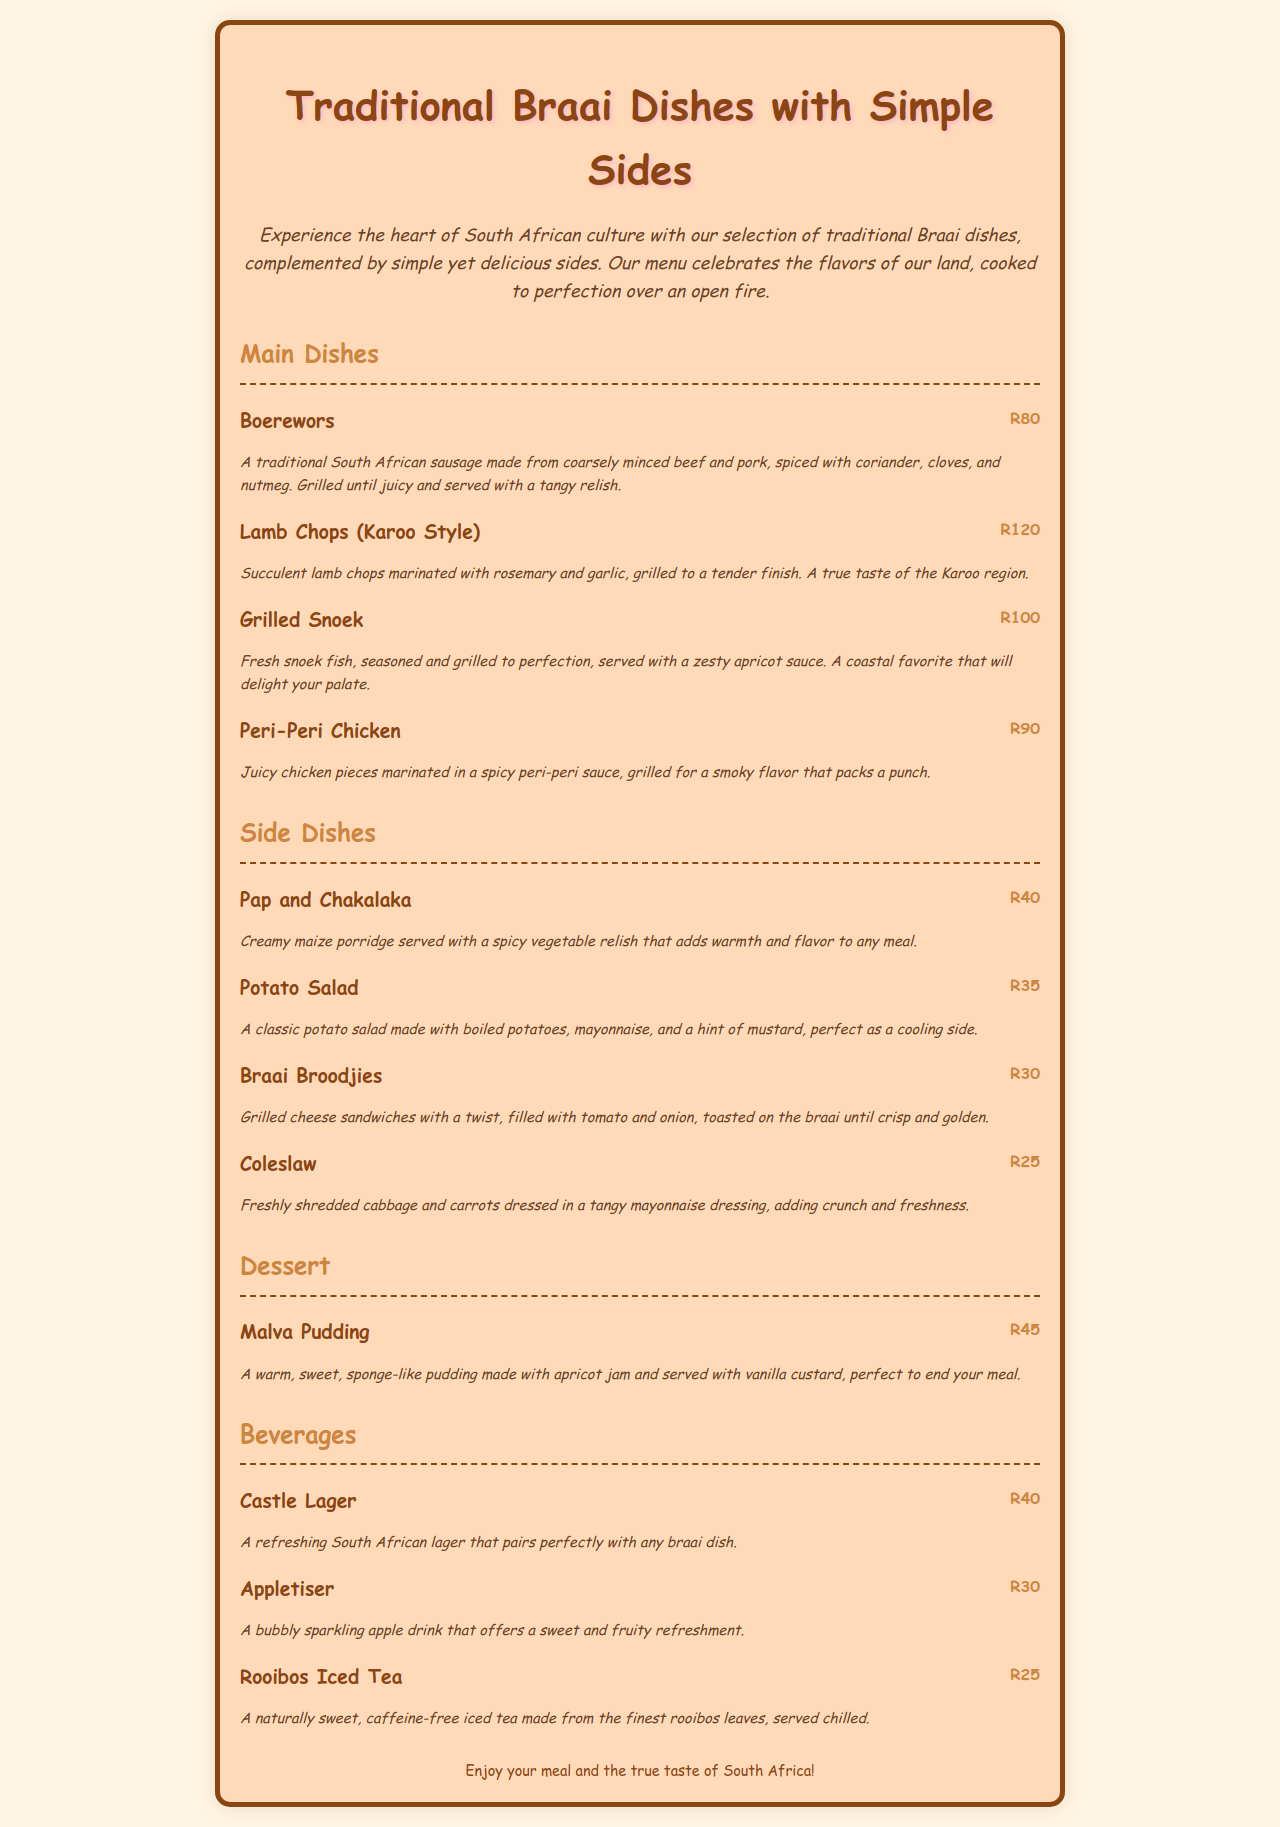What is the title of the menu? The title is prominently displayed at the top of the document, indicating the theme of the menu.
Answer: Traditional Braai Dishes with Simple Sides How much do Boerewors cost? The price is listed next to the item on the menu, providing straightforward pricing information.
Answer: R80 What is included in the Pap and Chakalaka dish? The description provides key components of the dish, informing about its main ingredients.
Answer: Creamy maize porridge and spicy vegetable relish What type of dessert is offered? The dessert section of the menu indicates the specific item available for sweet cravings.
Answer: Malva Pudding Which beverage costs the least? By comparing the prices of all beverages listed, we can determine which one is the most affordable.
Answer: Rooibos Iced Tea How are the lamb chops prepared? The description provides details about the preparation method and flavoring.
Answer: Marinated with rosemary and garlic, grilled What side dish is known for its crunch and freshness? The information in the side dishes section highlights the qualities of specific dishes.
Answer: Coleslaw What is served with the Grilled Snoek? The description states what accompanies the main dish, providing insight into its serving details.
Answer: Zesty apricot sauce How many main dish options are available? By counting the entries under the Main Dishes section, we can determine the total number offered.
Answer: Four 